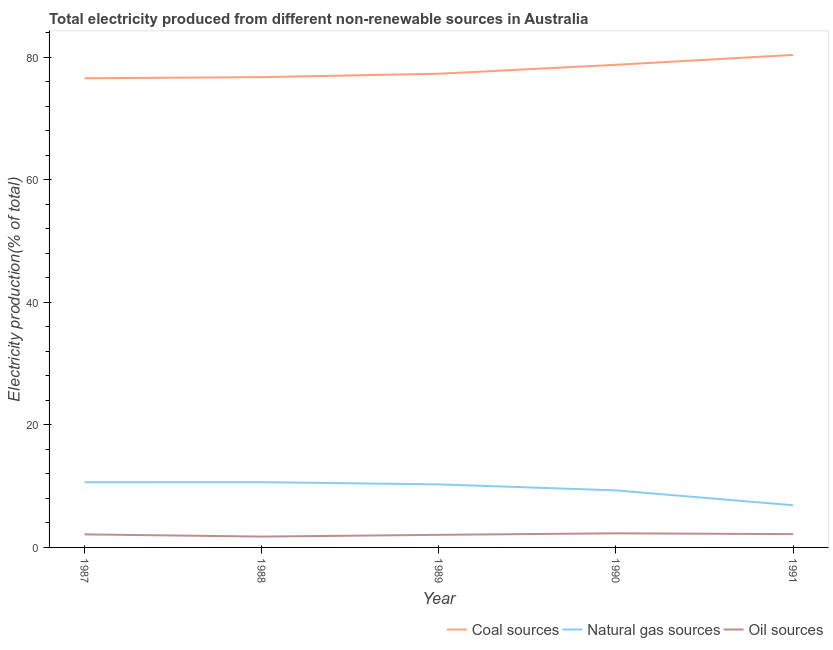How many different coloured lines are there?
Provide a short and direct response. 3. Is the number of lines equal to the number of legend labels?
Provide a short and direct response. Yes. What is the percentage of electricity produced by oil sources in 1988?
Make the answer very short. 1.77. Across all years, what is the maximum percentage of electricity produced by coal?
Your answer should be compact. 80.35. Across all years, what is the minimum percentage of electricity produced by coal?
Provide a short and direct response. 76.54. In which year was the percentage of electricity produced by coal maximum?
Your answer should be very brief. 1991. What is the total percentage of electricity produced by natural gas in the graph?
Provide a succinct answer. 47.75. What is the difference between the percentage of electricity produced by oil sources in 1989 and that in 1990?
Offer a terse response. -0.25. What is the difference between the percentage of electricity produced by coal in 1989 and the percentage of electricity produced by natural gas in 1987?
Provide a succinct answer. 66.64. What is the average percentage of electricity produced by oil sources per year?
Ensure brevity in your answer.  2.08. In the year 1989, what is the difference between the percentage of electricity produced by natural gas and percentage of electricity produced by oil sources?
Ensure brevity in your answer.  8.23. What is the ratio of the percentage of electricity produced by oil sources in 1989 to that in 1990?
Give a very brief answer. 0.89. Is the difference between the percentage of electricity produced by oil sources in 1988 and 1990 greater than the difference between the percentage of electricity produced by natural gas in 1988 and 1990?
Make the answer very short. No. What is the difference between the highest and the second highest percentage of electricity produced by coal?
Your answer should be very brief. 1.62. What is the difference between the highest and the lowest percentage of electricity produced by coal?
Ensure brevity in your answer.  3.81. In how many years, is the percentage of electricity produced by coal greater than the average percentage of electricity produced by coal taken over all years?
Your response must be concise. 2. Is the sum of the percentage of electricity produced by oil sources in 1987 and 1988 greater than the maximum percentage of electricity produced by natural gas across all years?
Make the answer very short. No. Does the percentage of electricity produced by oil sources monotonically increase over the years?
Provide a succinct answer. No. Is the percentage of electricity produced by coal strictly greater than the percentage of electricity produced by oil sources over the years?
Provide a short and direct response. Yes. How many lines are there?
Your response must be concise. 3. How many years are there in the graph?
Offer a terse response. 5. Does the graph contain any zero values?
Give a very brief answer. No. Does the graph contain grids?
Provide a succinct answer. No. What is the title of the graph?
Your answer should be very brief. Total electricity produced from different non-renewable sources in Australia. Does "Agriculture" appear as one of the legend labels in the graph?
Your response must be concise. No. What is the label or title of the X-axis?
Make the answer very short. Year. What is the Electricity production(% of total) in Coal sources in 1987?
Your answer should be compact. 76.54. What is the Electricity production(% of total) of Natural gas sources in 1987?
Keep it short and to the point. 10.64. What is the Electricity production(% of total) in Oil sources in 1987?
Offer a very short reply. 2.13. What is the Electricity production(% of total) of Coal sources in 1988?
Your answer should be compact. 76.72. What is the Electricity production(% of total) of Natural gas sources in 1988?
Offer a very short reply. 10.64. What is the Electricity production(% of total) in Oil sources in 1988?
Keep it short and to the point. 1.77. What is the Electricity production(% of total) in Coal sources in 1989?
Provide a short and direct response. 77.28. What is the Electricity production(% of total) in Natural gas sources in 1989?
Provide a short and direct response. 10.29. What is the Electricity production(% of total) of Oil sources in 1989?
Keep it short and to the point. 2.06. What is the Electricity production(% of total) of Coal sources in 1990?
Offer a terse response. 78.74. What is the Electricity production(% of total) of Natural gas sources in 1990?
Keep it short and to the point. 9.31. What is the Electricity production(% of total) in Oil sources in 1990?
Offer a very short reply. 2.3. What is the Electricity production(% of total) in Coal sources in 1991?
Give a very brief answer. 80.35. What is the Electricity production(% of total) in Natural gas sources in 1991?
Ensure brevity in your answer.  6.88. What is the Electricity production(% of total) of Oil sources in 1991?
Your response must be concise. 2.17. Across all years, what is the maximum Electricity production(% of total) of Coal sources?
Your response must be concise. 80.35. Across all years, what is the maximum Electricity production(% of total) of Natural gas sources?
Your answer should be very brief. 10.64. Across all years, what is the maximum Electricity production(% of total) in Oil sources?
Your answer should be very brief. 2.3. Across all years, what is the minimum Electricity production(% of total) of Coal sources?
Keep it short and to the point. 76.54. Across all years, what is the minimum Electricity production(% of total) in Natural gas sources?
Your response must be concise. 6.88. Across all years, what is the minimum Electricity production(% of total) of Oil sources?
Give a very brief answer. 1.77. What is the total Electricity production(% of total) of Coal sources in the graph?
Offer a terse response. 389.63. What is the total Electricity production(% of total) of Natural gas sources in the graph?
Ensure brevity in your answer.  47.75. What is the total Electricity production(% of total) in Oil sources in the graph?
Give a very brief answer. 10.42. What is the difference between the Electricity production(% of total) in Coal sources in 1987 and that in 1988?
Keep it short and to the point. -0.18. What is the difference between the Electricity production(% of total) in Natural gas sources in 1987 and that in 1988?
Make the answer very short. -0.01. What is the difference between the Electricity production(% of total) of Oil sources in 1987 and that in 1988?
Keep it short and to the point. 0.36. What is the difference between the Electricity production(% of total) in Coal sources in 1987 and that in 1989?
Offer a terse response. -0.74. What is the difference between the Electricity production(% of total) in Natural gas sources in 1987 and that in 1989?
Provide a succinct answer. 0.35. What is the difference between the Electricity production(% of total) in Oil sources in 1987 and that in 1989?
Keep it short and to the point. 0.07. What is the difference between the Electricity production(% of total) of Coal sources in 1987 and that in 1990?
Give a very brief answer. -2.19. What is the difference between the Electricity production(% of total) in Natural gas sources in 1987 and that in 1990?
Your response must be concise. 1.33. What is the difference between the Electricity production(% of total) in Oil sources in 1987 and that in 1990?
Make the answer very short. -0.17. What is the difference between the Electricity production(% of total) in Coal sources in 1987 and that in 1991?
Give a very brief answer. -3.81. What is the difference between the Electricity production(% of total) in Natural gas sources in 1987 and that in 1991?
Ensure brevity in your answer.  3.75. What is the difference between the Electricity production(% of total) of Oil sources in 1987 and that in 1991?
Your answer should be very brief. -0.04. What is the difference between the Electricity production(% of total) of Coal sources in 1988 and that in 1989?
Your response must be concise. -0.56. What is the difference between the Electricity production(% of total) of Natural gas sources in 1988 and that in 1989?
Your answer should be compact. 0.36. What is the difference between the Electricity production(% of total) in Oil sources in 1988 and that in 1989?
Keep it short and to the point. -0.29. What is the difference between the Electricity production(% of total) of Coal sources in 1988 and that in 1990?
Provide a short and direct response. -2.01. What is the difference between the Electricity production(% of total) of Natural gas sources in 1988 and that in 1990?
Provide a short and direct response. 1.34. What is the difference between the Electricity production(% of total) in Oil sources in 1988 and that in 1990?
Offer a terse response. -0.54. What is the difference between the Electricity production(% of total) in Coal sources in 1988 and that in 1991?
Your answer should be very brief. -3.63. What is the difference between the Electricity production(% of total) in Natural gas sources in 1988 and that in 1991?
Keep it short and to the point. 3.76. What is the difference between the Electricity production(% of total) of Oil sources in 1988 and that in 1991?
Make the answer very short. -0.4. What is the difference between the Electricity production(% of total) in Coal sources in 1989 and that in 1990?
Give a very brief answer. -1.46. What is the difference between the Electricity production(% of total) of Natural gas sources in 1989 and that in 1990?
Ensure brevity in your answer.  0.98. What is the difference between the Electricity production(% of total) of Oil sources in 1989 and that in 1990?
Offer a very short reply. -0.25. What is the difference between the Electricity production(% of total) in Coal sources in 1989 and that in 1991?
Give a very brief answer. -3.07. What is the difference between the Electricity production(% of total) in Natural gas sources in 1989 and that in 1991?
Your answer should be very brief. 3.4. What is the difference between the Electricity production(% of total) of Oil sources in 1989 and that in 1991?
Offer a terse response. -0.11. What is the difference between the Electricity production(% of total) in Coal sources in 1990 and that in 1991?
Your answer should be very brief. -1.62. What is the difference between the Electricity production(% of total) of Natural gas sources in 1990 and that in 1991?
Keep it short and to the point. 2.43. What is the difference between the Electricity production(% of total) of Oil sources in 1990 and that in 1991?
Offer a very short reply. 0.13. What is the difference between the Electricity production(% of total) in Coal sources in 1987 and the Electricity production(% of total) in Natural gas sources in 1988?
Keep it short and to the point. 65.9. What is the difference between the Electricity production(% of total) in Coal sources in 1987 and the Electricity production(% of total) in Oil sources in 1988?
Provide a succinct answer. 74.77. What is the difference between the Electricity production(% of total) of Natural gas sources in 1987 and the Electricity production(% of total) of Oil sources in 1988?
Your answer should be compact. 8.87. What is the difference between the Electricity production(% of total) in Coal sources in 1987 and the Electricity production(% of total) in Natural gas sources in 1989?
Offer a very short reply. 66.25. What is the difference between the Electricity production(% of total) of Coal sources in 1987 and the Electricity production(% of total) of Oil sources in 1989?
Ensure brevity in your answer.  74.48. What is the difference between the Electricity production(% of total) in Natural gas sources in 1987 and the Electricity production(% of total) in Oil sources in 1989?
Provide a short and direct response. 8.58. What is the difference between the Electricity production(% of total) in Coal sources in 1987 and the Electricity production(% of total) in Natural gas sources in 1990?
Offer a terse response. 67.23. What is the difference between the Electricity production(% of total) of Coal sources in 1987 and the Electricity production(% of total) of Oil sources in 1990?
Keep it short and to the point. 74.24. What is the difference between the Electricity production(% of total) of Natural gas sources in 1987 and the Electricity production(% of total) of Oil sources in 1990?
Provide a short and direct response. 8.33. What is the difference between the Electricity production(% of total) in Coal sources in 1987 and the Electricity production(% of total) in Natural gas sources in 1991?
Ensure brevity in your answer.  69.66. What is the difference between the Electricity production(% of total) of Coal sources in 1987 and the Electricity production(% of total) of Oil sources in 1991?
Provide a short and direct response. 74.37. What is the difference between the Electricity production(% of total) of Natural gas sources in 1987 and the Electricity production(% of total) of Oil sources in 1991?
Give a very brief answer. 8.47. What is the difference between the Electricity production(% of total) of Coal sources in 1988 and the Electricity production(% of total) of Natural gas sources in 1989?
Offer a very short reply. 66.44. What is the difference between the Electricity production(% of total) in Coal sources in 1988 and the Electricity production(% of total) in Oil sources in 1989?
Provide a short and direct response. 74.67. What is the difference between the Electricity production(% of total) of Natural gas sources in 1988 and the Electricity production(% of total) of Oil sources in 1989?
Your response must be concise. 8.59. What is the difference between the Electricity production(% of total) of Coal sources in 1988 and the Electricity production(% of total) of Natural gas sources in 1990?
Your response must be concise. 67.42. What is the difference between the Electricity production(% of total) in Coal sources in 1988 and the Electricity production(% of total) in Oil sources in 1990?
Offer a very short reply. 74.42. What is the difference between the Electricity production(% of total) of Natural gas sources in 1988 and the Electricity production(% of total) of Oil sources in 1990?
Offer a terse response. 8.34. What is the difference between the Electricity production(% of total) of Coal sources in 1988 and the Electricity production(% of total) of Natural gas sources in 1991?
Keep it short and to the point. 69.84. What is the difference between the Electricity production(% of total) in Coal sources in 1988 and the Electricity production(% of total) in Oil sources in 1991?
Provide a succinct answer. 74.55. What is the difference between the Electricity production(% of total) of Natural gas sources in 1988 and the Electricity production(% of total) of Oil sources in 1991?
Your answer should be very brief. 8.47. What is the difference between the Electricity production(% of total) in Coal sources in 1989 and the Electricity production(% of total) in Natural gas sources in 1990?
Your answer should be very brief. 67.97. What is the difference between the Electricity production(% of total) of Coal sources in 1989 and the Electricity production(% of total) of Oil sources in 1990?
Ensure brevity in your answer.  74.98. What is the difference between the Electricity production(% of total) in Natural gas sources in 1989 and the Electricity production(% of total) in Oil sources in 1990?
Your response must be concise. 7.98. What is the difference between the Electricity production(% of total) in Coal sources in 1989 and the Electricity production(% of total) in Natural gas sources in 1991?
Offer a terse response. 70.4. What is the difference between the Electricity production(% of total) in Coal sources in 1989 and the Electricity production(% of total) in Oil sources in 1991?
Offer a terse response. 75.11. What is the difference between the Electricity production(% of total) in Natural gas sources in 1989 and the Electricity production(% of total) in Oil sources in 1991?
Give a very brief answer. 8.12. What is the difference between the Electricity production(% of total) in Coal sources in 1990 and the Electricity production(% of total) in Natural gas sources in 1991?
Offer a very short reply. 71.85. What is the difference between the Electricity production(% of total) of Coal sources in 1990 and the Electricity production(% of total) of Oil sources in 1991?
Your answer should be very brief. 76.57. What is the difference between the Electricity production(% of total) of Natural gas sources in 1990 and the Electricity production(% of total) of Oil sources in 1991?
Offer a very short reply. 7.14. What is the average Electricity production(% of total) of Coal sources per year?
Your answer should be compact. 77.93. What is the average Electricity production(% of total) of Natural gas sources per year?
Your response must be concise. 9.55. What is the average Electricity production(% of total) in Oil sources per year?
Your answer should be very brief. 2.08. In the year 1987, what is the difference between the Electricity production(% of total) in Coal sources and Electricity production(% of total) in Natural gas sources?
Offer a terse response. 65.9. In the year 1987, what is the difference between the Electricity production(% of total) of Coal sources and Electricity production(% of total) of Oil sources?
Offer a very short reply. 74.41. In the year 1987, what is the difference between the Electricity production(% of total) of Natural gas sources and Electricity production(% of total) of Oil sources?
Make the answer very short. 8.51. In the year 1988, what is the difference between the Electricity production(% of total) of Coal sources and Electricity production(% of total) of Natural gas sources?
Offer a terse response. 66.08. In the year 1988, what is the difference between the Electricity production(% of total) in Coal sources and Electricity production(% of total) in Oil sources?
Offer a very short reply. 74.96. In the year 1988, what is the difference between the Electricity production(% of total) in Natural gas sources and Electricity production(% of total) in Oil sources?
Keep it short and to the point. 8.88. In the year 1989, what is the difference between the Electricity production(% of total) in Coal sources and Electricity production(% of total) in Natural gas sources?
Offer a very short reply. 66.99. In the year 1989, what is the difference between the Electricity production(% of total) in Coal sources and Electricity production(% of total) in Oil sources?
Keep it short and to the point. 75.22. In the year 1989, what is the difference between the Electricity production(% of total) of Natural gas sources and Electricity production(% of total) of Oil sources?
Your answer should be very brief. 8.23. In the year 1990, what is the difference between the Electricity production(% of total) of Coal sources and Electricity production(% of total) of Natural gas sources?
Your response must be concise. 69.43. In the year 1990, what is the difference between the Electricity production(% of total) in Coal sources and Electricity production(% of total) in Oil sources?
Keep it short and to the point. 76.43. In the year 1990, what is the difference between the Electricity production(% of total) in Natural gas sources and Electricity production(% of total) in Oil sources?
Provide a succinct answer. 7. In the year 1991, what is the difference between the Electricity production(% of total) in Coal sources and Electricity production(% of total) in Natural gas sources?
Offer a very short reply. 73.47. In the year 1991, what is the difference between the Electricity production(% of total) of Coal sources and Electricity production(% of total) of Oil sources?
Your response must be concise. 78.18. In the year 1991, what is the difference between the Electricity production(% of total) of Natural gas sources and Electricity production(% of total) of Oil sources?
Provide a short and direct response. 4.71. What is the ratio of the Electricity production(% of total) of Oil sources in 1987 to that in 1988?
Provide a short and direct response. 1.2. What is the ratio of the Electricity production(% of total) in Coal sources in 1987 to that in 1989?
Your response must be concise. 0.99. What is the ratio of the Electricity production(% of total) of Natural gas sources in 1987 to that in 1989?
Give a very brief answer. 1.03. What is the ratio of the Electricity production(% of total) in Oil sources in 1987 to that in 1989?
Your answer should be compact. 1.04. What is the ratio of the Electricity production(% of total) in Coal sources in 1987 to that in 1990?
Your response must be concise. 0.97. What is the ratio of the Electricity production(% of total) in Natural gas sources in 1987 to that in 1990?
Offer a very short reply. 1.14. What is the ratio of the Electricity production(% of total) in Oil sources in 1987 to that in 1990?
Offer a very short reply. 0.92. What is the ratio of the Electricity production(% of total) of Coal sources in 1987 to that in 1991?
Ensure brevity in your answer.  0.95. What is the ratio of the Electricity production(% of total) in Natural gas sources in 1987 to that in 1991?
Ensure brevity in your answer.  1.55. What is the ratio of the Electricity production(% of total) of Oil sources in 1987 to that in 1991?
Provide a short and direct response. 0.98. What is the ratio of the Electricity production(% of total) of Natural gas sources in 1988 to that in 1989?
Your answer should be very brief. 1.03. What is the ratio of the Electricity production(% of total) of Oil sources in 1988 to that in 1989?
Provide a succinct answer. 0.86. What is the ratio of the Electricity production(% of total) of Coal sources in 1988 to that in 1990?
Keep it short and to the point. 0.97. What is the ratio of the Electricity production(% of total) in Natural gas sources in 1988 to that in 1990?
Ensure brevity in your answer.  1.14. What is the ratio of the Electricity production(% of total) in Oil sources in 1988 to that in 1990?
Make the answer very short. 0.77. What is the ratio of the Electricity production(% of total) in Coal sources in 1988 to that in 1991?
Your response must be concise. 0.95. What is the ratio of the Electricity production(% of total) of Natural gas sources in 1988 to that in 1991?
Your answer should be very brief. 1.55. What is the ratio of the Electricity production(% of total) in Oil sources in 1988 to that in 1991?
Your answer should be compact. 0.81. What is the ratio of the Electricity production(% of total) in Coal sources in 1989 to that in 1990?
Make the answer very short. 0.98. What is the ratio of the Electricity production(% of total) of Natural gas sources in 1989 to that in 1990?
Give a very brief answer. 1.11. What is the ratio of the Electricity production(% of total) in Oil sources in 1989 to that in 1990?
Offer a terse response. 0.89. What is the ratio of the Electricity production(% of total) in Coal sources in 1989 to that in 1991?
Offer a terse response. 0.96. What is the ratio of the Electricity production(% of total) of Natural gas sources in 1989 to that in 1991?
Your response must be concise. 1.49. What is the ratio of the Electricity production(% of total) of Oil sources in 1989 to that in 1991?
Keep it short and to the point. 0.95. What is the ratio of the Electricity production(% of total) in Coal sources in 1990 to that in 1991?
Give a very brief answer. 0.98. What is the ratio of the Electricity production(% of total) of Natural gas sources in 1990 to that in 1991?
Your response must be concise. 1.35. What is the ratio of the Electricity production(% of total) of Oil sources in 1990 to that in 1991?
Make the answer very short. 1.06. What is the difference between the highest and the second highest Electricity production(% of total) of Coal sources?
Keep it short and to the point. 1.62. What is the difference between the highest and the second highest Electricity production(% of total) in Natural gas sources?
Your answer should be compact. 0.01. What is the difference between the highest and the second highest Electricity production(% of total) in Oil sources?
Make the answer very short. 0.13. What is the difference between the highest and the lowest Electricity production(% of total) of Coal sources?
Keep it short and to the point. 3.81. What is the difference between the highest and the lowest Electricity production(% of total) of Natural gas sources?
Ensure brevity in your answer.  3.76. What is the difference between the highest and the lowest Electricity production(% of total) of Oil sources?
Keep it short and to the point. 0.54. 